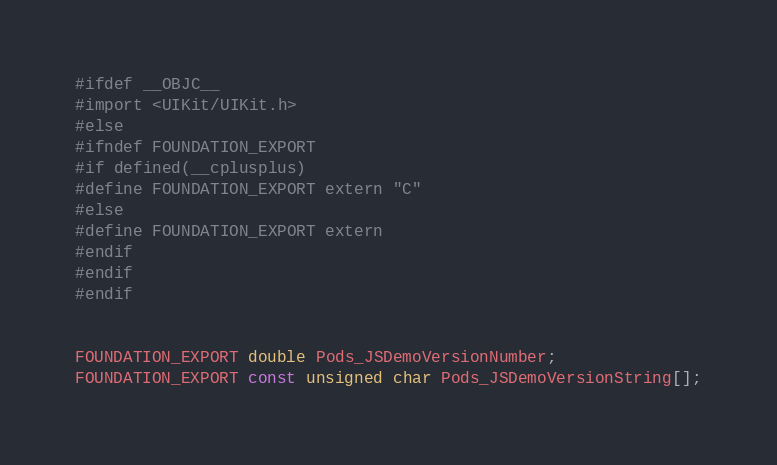<code> <loc_0><loc_0><loc_500><loc_500><_C_>#ifdef __OBJC__
#import <UIKit/UIKit.h>
#else
#ifndef FOUNDATION_EXPORT
#if defined(__cplusplus)
#define FOUNDATION_EXPORT extern "C"
#else
#define FOUNDATION_EXPORT extern
#endif
#endif
#endif


FOUNDATION_EXPORT double Pods_JSDemoVersionNumber;
FOUNDATION_EXPORT const unsigned char Pods_JSDemoVersionString[];

</code> 